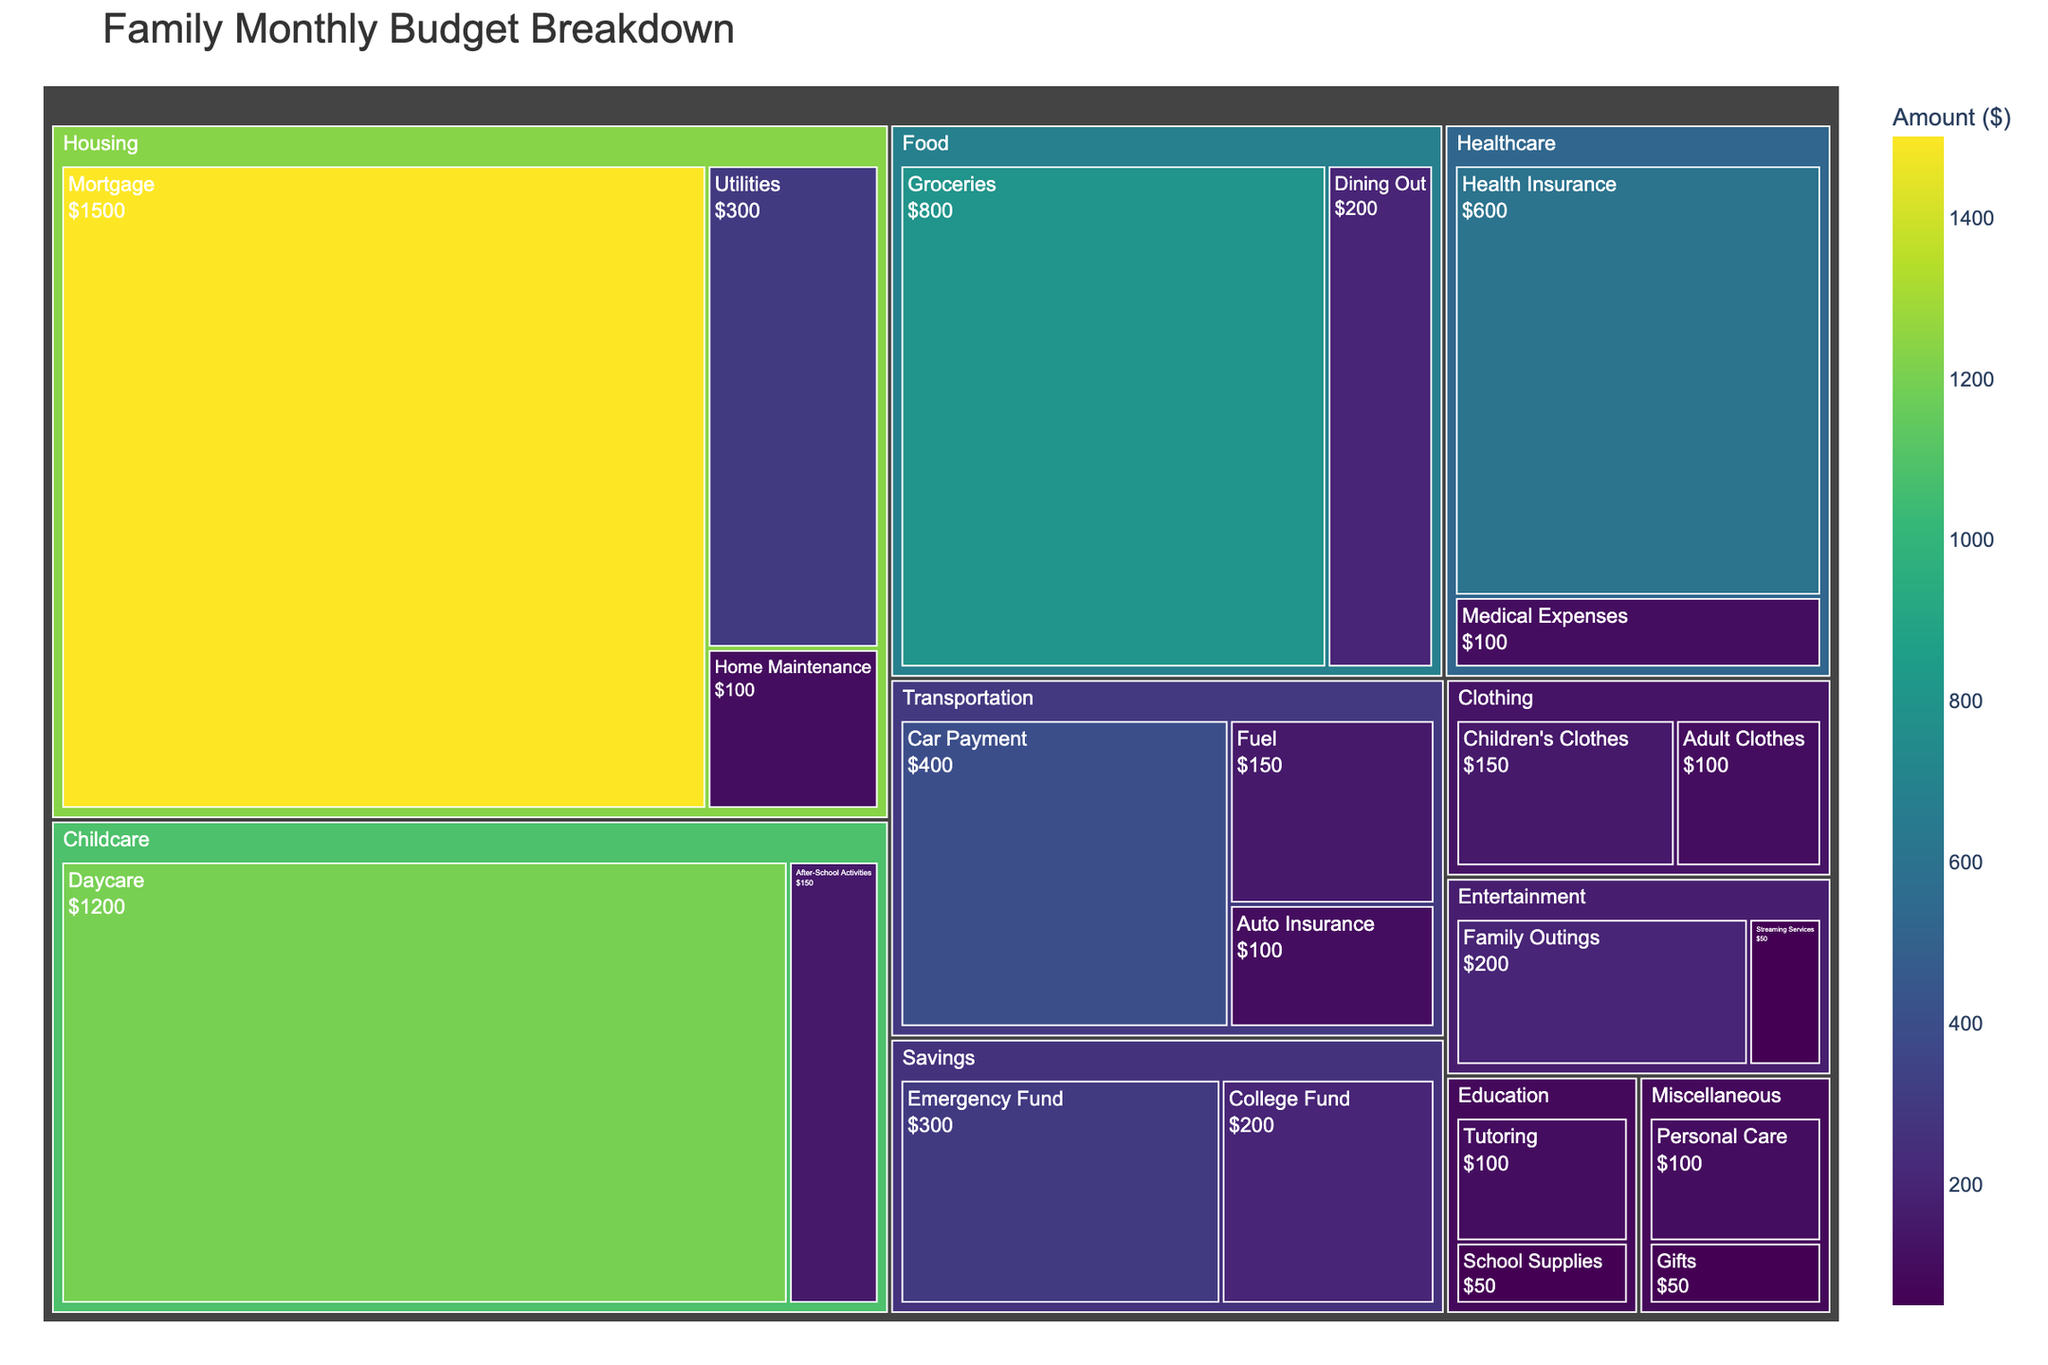What is the largest expense in the family's monthly budget? Examining the treemap, the largest expense is represented by the largest tile, which is "Daycare" under the "Childcare" category.
Answer: Daycare How much does the family spend on Housing in total? Summing up the amounts for all subcategories under Housing (Mortgage, Utilities, Home Maintenance): 1500 + 300 + 100 = 1900
Answer: 1900 Which category has the smallest total expenditure? Looking at the smallest category (tile) in the treemap with the least combined area, the "Education" category has the smallest total expenditure (School Supplies and Tutoring).
Answer: Education What is the combined amount spent on children's clothes and adult clothes? Adding the expenditures for "Children's Clothes" and "Adult Clothes" under the "Clothing" category: 150 + 100 = 250
Answer: 250 How much more does the family spend on Groceries compared to Dining Out? Subtracting the expense for Dining Out from Groceries: 800 (Groceries) - 200 (Dining Out) = 600
Answer: 600 What percentage of the budget is spent on childcare-related expenses? Calculating the sum of all amounts and childcare expenses, then dividing the childcare expenses by the total and multiplying by 100. Total = 6600, Childcare = 1350. Percentage = (1350 / 6600) * 100 ≈ 20.45%
Answer: 20.45% Which expense is greater: Fuel or Car Payment? Comparing the amounts for Fuel (150) and Car Payment (400), the Car Payment is greater.
Answer: Car Payment How does the spending on healthcare compare to the spending on savings? Adding the amounts for Health Insurance and Medical Expenses to compare with the sums for Emergency Fund and College Fund: Healthcare = 600 + 100 = 700, Savings = 300 + 200 = 500. Healthcare expenses are greater than Savings.
Answer: Healthcare What are the child-related expenses represented in the treemap? Identifying all subcategories related to children: Daycare (1200), After-School Activities (150), Children's Clothes (150).
Answer: Daycare, After-School Activities, Children's Clothes What is the combined amount spent on Transportation? Summing up the amounts for Car Payment, Fuel, and Auto Insurance under the "Transportation" category: 400 + 150 + 100 = 650
Answer: 650 